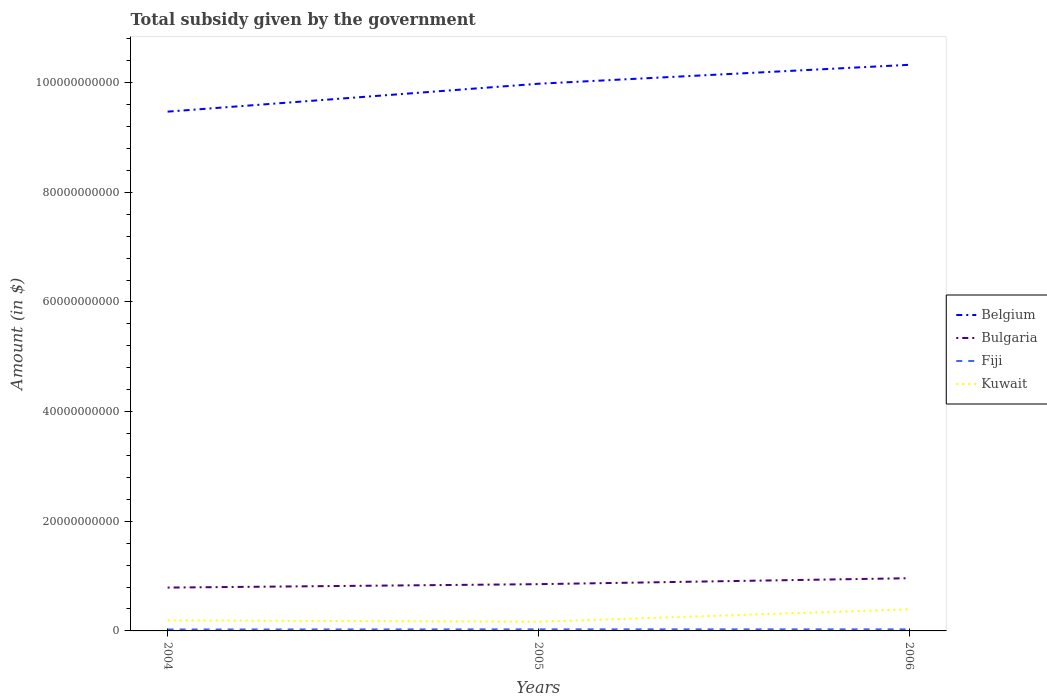Is the number of lines equal to the number of legend labels?
Keep it short and to the point. Yes. Across all years, what is the maximum total revenue collected by the government in Kuwait?
Give a very brief answer. 1.68e+09. What is the total total revenue collected by the government in Belgium in the graph?
Ensure brevity in your answer.  -5.09e+09. What is the difference between the highest and the second highest total revenue collected by the government in Fiji?
Offer a terse response. 2.69e+07. What is the difference between the highest and the lowest total revenue collected by the government in Kuwait?
Provide a short and direct response. 1. How many lines are there?
Offer a very short reply. 4. How many years are there in the graph?
Offer a terse response. 3. Does the graph contain any zero values?
Keep it short and to the point. No. Does the graph contain grids?
Ensure brevity in your answer.  No. What is the title of the graph?
Your answer should be compact. Total subsidy given by the government. What is the label or title of the X-axis?
Ensure brevity in your answer.  Years. What is the label or title of the Y-axis?
Offer a very short reply. Amount (in $). What is the Amount (in $) in Belgium in 2004?
Offer a terse response. 9.47e+1. What is the Amount (in $) in Bulgaria in 2004?
Your response must be concise. 7.91e+09. What is the Amount (in $) in Fiji in 2004?
Provide a short and direct response. 2.62e+08. What is the Amount (in $) in Kuwait in 2004?
Your answer should be compact. 1.93e+09. What is the Amount (in $) of Belgium in 2005?
Your response must be concise. 9.98e+1. What is the Amount (in $) of Bulgaria in 2005?
Keep it short and to the point. 8.53e+09. What is the Amount (in $) in Fiji in 2005?
Provide a short and direct response. 2.88e+08. What is the Amount (in $) in Kuwait in 2005?
Your answer should be compact. 1.68e+09. What is the Amount (in $) in Belgium in 2006?
Keep it short and to the point. 1.03e+11. What is the Amount (in $) in Bulgaria in 2006?
Give a very brief answer. 9.61e+09. What is the Amount (in $) of Fiji in 2006?
Offer a terse response. 2.89e+08. What is the Amount (in $) of Kuwait in 2006?
Offer a terse response. 3.94e+09. Across all years, what is the maximum Amount (in $) in Belgium?
Give a very brief answer. 1.03e+11. Across all years, what is the maximum Amount (in $) in Bulgaria?
Ensure brevity in your answer.  9.61e+09. Across all years, what is the maximum Amount (in $) in Fiji?
Give a very brief answer. 2.89e+08. Across all years, what is the maximum Amount (in $) of Kuwait?
Make the answer very short. 3.94e+09. Across all years, what is the minimum Amount (in $) of Belgium?
Provide a succinct answer. 9.47e+1. Across all years, what is the minimum Amount (in $) in Bulgaria?
Keep it short and to the point. 7.91e+09. Across all years, what is the minimum Amount (in $) of Fiji?
Ensure brevity in your answer.  2.62e+08. Across all years, what is the minimum Amount (in $) of Kuwait?
Give a very brief answer. 1.68e+09. What is the total Amount (in $) in Belgium in the graph?
Keep it short and to the point. 2.98e+11. What is the total Amount (in $) in Bulgaria in the graph?
Make the answer very short. 2.60e+1. What is the total Amount (in $) of Fiji in the graph?
Provide a short and direct response. 8.38e+08. What is the total Amount (in $) of Kuwait in the graph?
Provide a short and direct response. 7.54e+09. What is the difference between the Amount (in $) in Belgium in 2004 and that in 2005?
Offer a terse response. -5.09e+09. What is the difference between the Amount (in $) in Bulgaria in 2004 and that in 2005?
Make the answer very short. -6.22e+08. What is the difference between the Amount (in $) in Fiji in 2004 and that in 2005?
Your answer should be very brief. -2.60e+07. What is the difference between the Amount (in $) in Kuwait in 2004 and that in 2005?
Give a very brief answer. 2.49e+08. What is the difference between the Amount (in $) of Belgium in 2004 and that in 2006?
Keep it short and to the point. -8.54e+09. What is the difference between the Amount (in $) in Bulgaria in 2004 and that in 2006?
Your answer should be very brief. -1.71e+09. What is the difference between the Amount (in $) of Fiji in 2004 and that in 2006?
Make the answer very short. -2.69e+07. What is the difference between the Amount (in $) of Kuwait in 2004 and that in 2006?
Your answer should be compact. -2.01e+09. What is the difference between the Amount (in $) in Belgium in 2005 and that in 2006?
Your response must be concise. -3.46e+09. What is the difference between the Amount (in $) of Bulgaria in 2005 and that in 2006?
Offer a terse response. -1.09e+09. What is the difference between the Amount (in $) in Fiji in 2005 and that in 2006?
Provide a succinct answer. -8.75e+05. What is the difference between the Amount (in $) in Kuwait in 2005 and that in 2006?
Provide a succinct answer. -2.26e+09. What is the difference between the Amount (in $) in Belgium in 2004 and the Amount (in $) in Bulgaria in 2005?
Provide a succinct answer. 8.62e+1. What is the difference between the Amount (in $) in Belgium in 2004 and the Amount (in $) in Fiji in 2005?
Your answer should be compact. 9.44e+1. What is the difference between the Amount (in $) of Belgium in 2004 and the Amount (in $) of Kuwait in 2005?
Provide a succinct answer. 9.30e+1. What is the difference between the Amount (in $) in Bulgaria in 2004 and the Amount (in $) in Fiji in 2005?
Offer a terse response. 7.62e+09. What is the difference between the Amount (in $) of Bulgaria in 2004 and the Amount (in $) of Kuwait in 2005?
Your answer should be compact. 6.23e+09. What is the difference between the Amount (in $) in Fiji in 2004 and the Amount (in $) in Kuwait in 2005?
Offer a terse response. -1.42e+09. What is the difference between the Amount (in $) of Belgium in 2004 and the Amount (in $) of Bulgaria in 2006?
Your answer should be compact. 8.51e+1. What is the difference between the Amount (in $) of Belgium in 2004 and the Amount (in $) of Fiji in 2006?
Give a very brief answer. 9.44e+1. What is the difference between the Amount (in $) in Belgium in 2004 and the Amount (in $) in Kuwait in 2006?
Ensure brevity in your answer.  9.08e+1. What is the difference between the Amount (in $) in Bulgaria in 2004 and the Amount (in $) in Fiji in 2006?
Keep it short and to the point. 7.62e+09. What is the difference between the Amount (in $) of Bulgaria in 2004 and the Amount (in $) of Kuwait in 2006?
Ensure brevity in your answer.  3.97e+09. What is the difference between the Amount (in $) of Fiji in 2004 and the Amount (in $) of Kuwait in 2006?
Give a very brief answer. -3.68e+09. What is the difference between the Amount (in $) of Belgium in 2005 and the Amount (in $) of Bulgaria in 2006?
Provide a succinct answer. 9.02e+1. What is the difference between the Amount (in $) of Belgium in 2005 and the Amount (in $) of Fiji in 2006?
Give a very brief answer. 9.95e+1. What is the difference between the Amount (in $) of Belgium in 2005 and the Amount (in $) of Kuwait in 2006?
Keep it short and to the point. 9.59e+1. What is the difference between the Amount (in $) of Bulgaria in 2005 and the Amount (in $) of Fiji in 2006?
Provide a short and direct response. 8.24e+09. What is the difference between the Amount (in $) of Bulgaria in 2005 and the Amount (in $) of Kuwait in 2006?
Ensure brevity in your answer.  4.59e+09. What is the difference between the Amount (in $) of Fiji in 2005 and the Amount (in $) of Kuwait in 2006?
Give a very brief answer. -3.65e+09. What is the average Amount (in $) of Belgium per year?
Your response must be concise. 9.93e+1. What is the average Amount (in $) of Bulgaria per year?
Offer a terse response. 8.68e+09. What is the average Amount (in $) in Fiji per year?
Make the answer very short. 2.79e+08. What is the average Amount (in $) of Kuwait per year?
Your answer should be very brief. 2.52e+09. In the year 2004, what is the difference between the Amount (in $) of Belgium and Amount (in $) of Bulgaria?
Offer a terse response. 8.68e+1. In the year 2004, what is the difference between the Amount (in $) in Belgium and Amount (in $) in Fiji?
Offer a very short reply. 9.44e+1. In the year 2004, what is the difference between the Amount (in $) in Belgium and Amount (in $) in Kuwait?
Your answer should be very brief. 9.28e+1. In the year 2004, what is the difference between the Amount (in $) of Bulgaria and Amount (in $) of Fiji?
Ensure brevity in your answer.  7.64e+09. In the year 2004, what is the difference between the Amount (in $) of Bulgaria and Amount (in $) of Kuwait?
Keep it short and to the point. 5.98e+09. In the year 2004, what is the difference between the Amount (in $) of Fiji and Amount (in $) of Kuwait?
Provide a succinct answer. -1.67e+09. In the year 2005, what is the difference between the Amount (in $) of Belgium and Amount (in $) of Bulgaria?
Keep it short and to the point. 9.13e+1. In the year 2005, what is the difference between the Amount (in $) in Belgium and Amount (in $) in Fiji?
Provide a short and direct response. 9.95e+1. In the year 2005, what is the difference between the Amount (in $) of Belgium and Amount (in $) of Kuwait?
Provide a short and direct response. 9.81e+1. In the year 2005, what is the difference between the Amount (in $) in Bulgaria and Amount (in $) in Fiji?
Offer a very short reply. 8.24e+09. In the year 2005, what is the difference between the Amount (in $) in Bulgaria and Amount (in $) in Kuwait?
Provide a succinct answer. 6.85e+09. In the year 2005, what is the difference between the Amount (in $) of Fiji and Amount (in $) of Kuwait?
Your answer should be compact. -1.39e+09. In the year 2006, what is the difference between the Amount (in $) of Belgium and Amount (in $) of Bulgaria?
Offer a very short reply. 9.36e+1. In the year 2006, what is the difference between the Amount (in $) of Belgium and Amount (in $) of Fiji?
Your response must be concise. 1.03e+11. In the year 2006, what is the difference between the Amount (in $) of Belgium and Amount (in $) of Kuwait?
Give a very brief answer. 9.93e+1. In the year 2006, what is the difference between the Amount (in $) of Bulgaria and Amount (in $) of Fiji?
Your response must be concise. 9.32e+09. In the year 2006, what is the difference between the Amount (in $) in Bulgaria and Amount (in $) in Kuwait?
Provide a succinct answer. 5.67e+09. In the year 2006, what is the difference between the Amount (in $) of Fiji and Amount (in $) of Kuwait?
Your answer should be very brief. -3.65e+09. What is the ratio of the Amount (in $) in Belgium in 2004 to that in 2005?
Your answer should be very brief. 0.95. What is the ratio of the Amount (in $) of Bulgaria in 2004 to that in 2005?
Your answer should be very brief. 0.93. What is the ratio of the Amount (in $) in Fiji in 2004 to that in 2005?
Your response must be concise. 0.91. What is the ratio of the Amount (in $) in Kuwait in 2004 to that in 2005?
Give a very brief answer. 1.15. What is the ratio of the Amount (in $) of Belgium in 2004 to that in 2006?
Your response must be concise. 0.92. What is the ratio of the Amount (in $) of Bulgaria in 2004 to that in 2006?
Ensure brevity in your answer.  0.82. What is the ratio of the Amount (in $) of Fiji in 2004 to that in 2006?
Provide a short and direct response. 0.91. What is the ratio of the Amount (in $) of Kuwait in 2004 to that in 2006?
Make the answer very short. 0.49. What is the ratio of the Amount (in $) of Belgium in 2005 to that in 2006?
Offer a very short reply. 0.97. What is the ratio of the Amount (in $) in Bulgaria in 2005 to that in 2006?
Your answer should be very brief. 0.89. What is the ratio of the Amount (in $) of Fiji in 2005 to that in 2006?
Keep it short and to the point. 1. What is the ratio of the Amount (in $) in Kuwait in 2005 to that in 2006?
Ensure brevity in your answer.  0.43. What is the difference between the highest and the second highest Amount (in $) of Belgium?
Your answer should be very brief. 3.46e+09. What is the difference between the highest and the second highest Amount (in $) of Bulgaria?
Give a very brief answer. 1.09e+09. What is the difference between the highest and the second highest Amount (in $) of Fiji?
Give a very brief answer. 8.75e+05. What is the difference between the highest and the second highest Amount (in $) in Kuwait?
Ensure brevity in your answer.  2.01e+09. What is the difference between the highest and the lowest Amount (in $) in Belgium?
Your response must be concise. 8.54e+09. What is the difference between the highest and the lowest Amount (in $) of Bulgaria?
Your answer should be very brief. 1.71e+09. What is the difference between the highest and the lowest Amount (in $) in Fiji?
Ensure brevity in your answer.  2.69e+07. What is the difference between the highest and the lowest Amount (in $) of Kuwait?
Ensure brevity in your answer.  2.26e+09. 